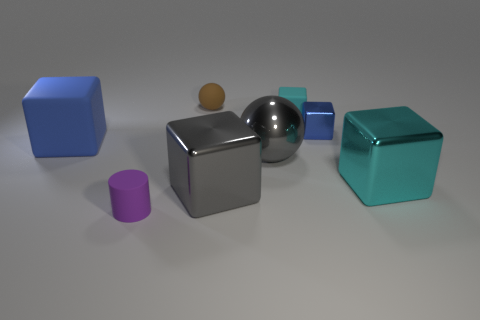What is the color of the matte cube that is the same size as the metal sphere?
Your answer should be compact. Blue. How many objects are either tiny purple metal cubes or tiny brown spheres?
Your answer should be compact. 1. There is a gray ball; are there any large cubes in front of it?
Keep it short and to the point. Yes. Is there a cyan thing that has the same material as the gray block?
Offer a very short reply. Yes. There is a metallic object that is the same color as the big ball; what size is it?
Ensure brevity in your answer.  Large. What number of cubes are either cyan metallic things or small purple rubber objects?
Provide a succinct answer. 1. Are there more brown objects that are behind the small brown thing than tiny blue objects to the left of the large gray metallic sphere?
Offer a very short reply. No. What number of metallic things have the same color as the big ball?
Your answer should be compact. 1. There is a blue cube that is made of the same material as the big cyan thing; what size is it?
Give a very brief answer. Small. How many things are either tiny rubber objects behind the small blue cube or small rubber balls?
Ensure brevity in your answer.  2. 